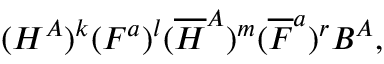<formula> <loc_0><loc_0><loc_500><loc_500>( H ^ { A } ) ^ { k } ( F ^ { a } ) ^ { l } ( { \overline { H } } ^ { A } ) ^ { m } ( { \overline { F } } ^ { a } ) ^ { r } B ^ { A } ,</formula> 